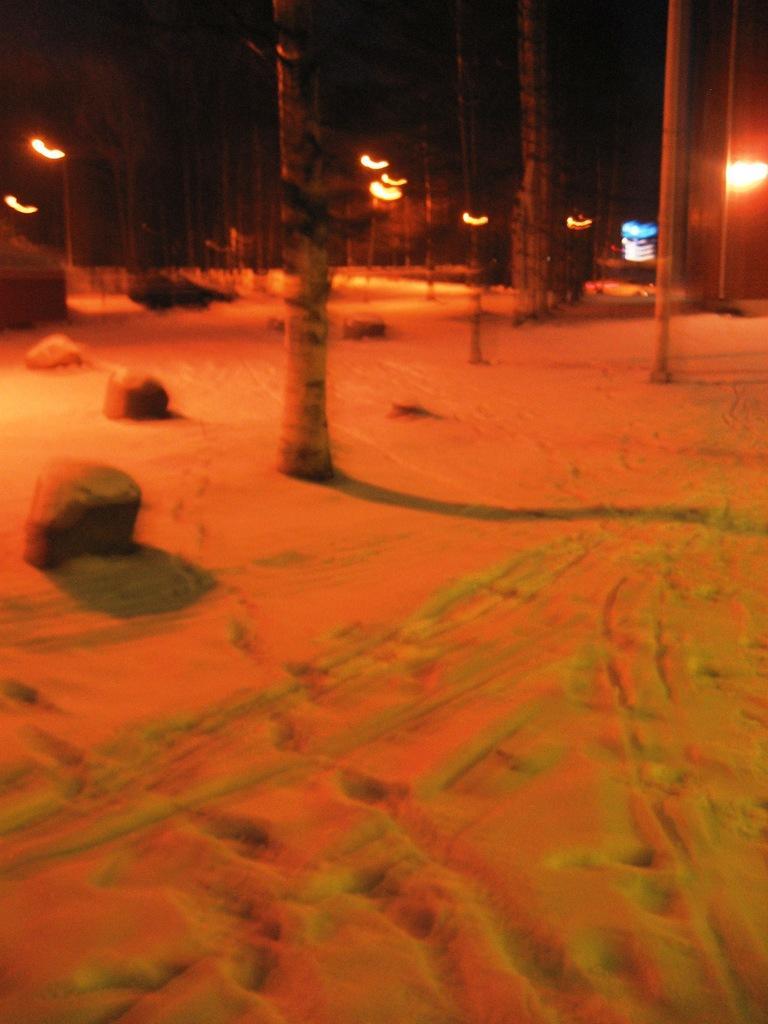Describe this image in one or two sentences. In this image, we can see the ground. We can see some rocks, trees. We can also see some lights. We can also see an object. 